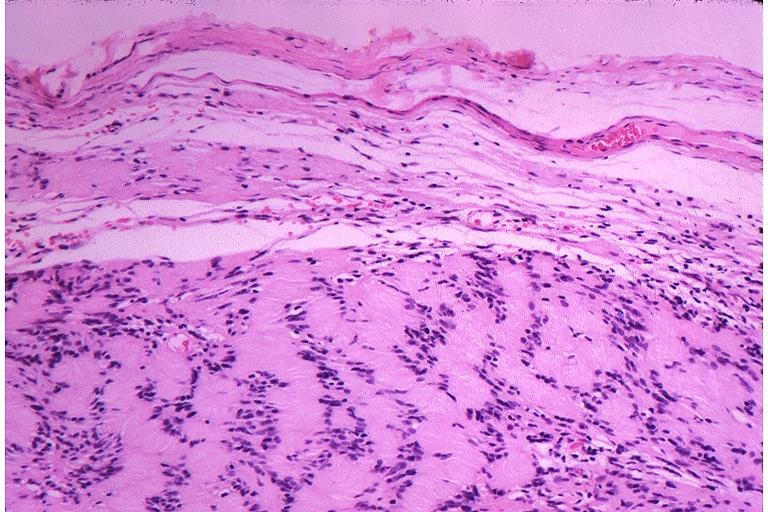what does this image show?
Answer the question using a single word or phrase. Schwanoma neurilemoma 